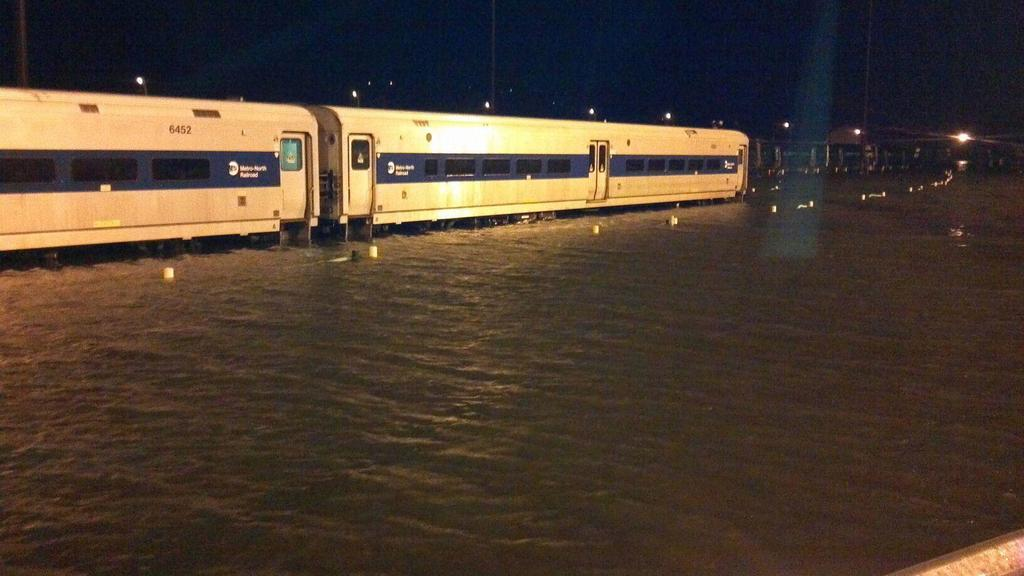What is one of the main elements visible in the image? There is water visible in the image. What mode of transportation can be seen in the image? There is a train in the image. Are there any artificial light sources visible in the image? Yes, there are lights visible in the image. How would you describe the color of the sky in the image? The sky appears to be white in color. What type of grass is growing near the train in the image? There is no grass visible in the image; it only features water, a train, lights, and a white sky. What color are the trousers worn by the spiders in the image? There are no spiders or trousers present in the image. 